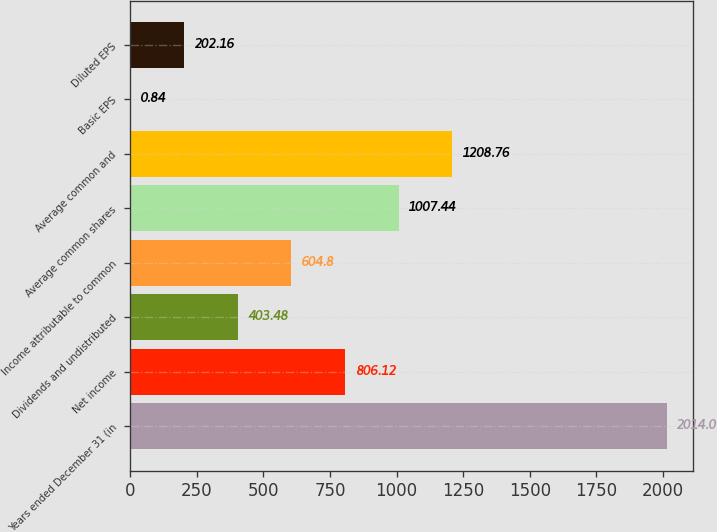<chart> <loc_0><loc_0><loc_500><loc_500><bar_chart><fcel>Years ended December 31 (in<fcel>Net income<fcel>Dividends and undistributed<fcel>Income attributable to common<fcel>Average common shares<fcel>Average common and<fcel>Basic EPS<fcel>Diluted EPS<nl><fcel>2014<fcel>806.12<fcel>403.48<fcel>604.8<fcel>1007.44<fcel>1208.76<fcel>0.84<fcel>202.16<nl></chart> 